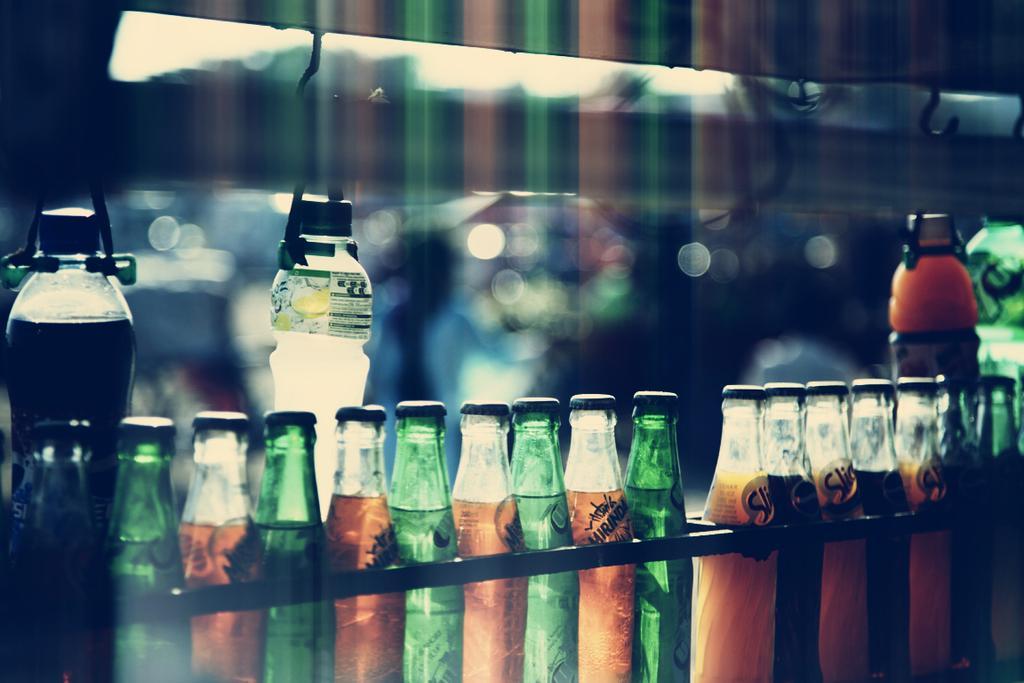Please provide a concise description of this image. This picture is mainly highlighted with a preservative cool drink bottles. We can see bottles changed over here with hooks. 